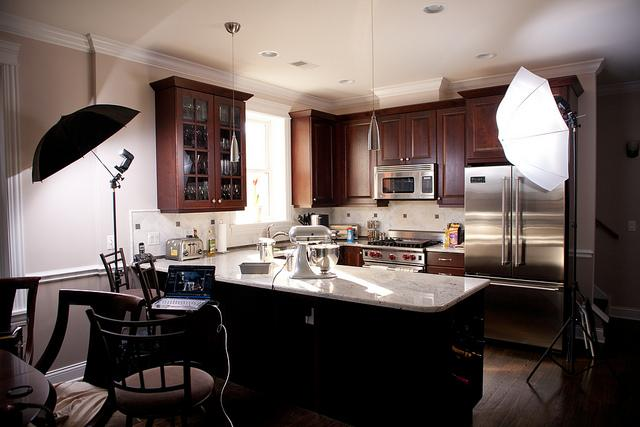What are the umbrellas being used for? Please explain your reasoning. lighting. These are professional lights that have umbrellas attached to them to help direct the lighting. 